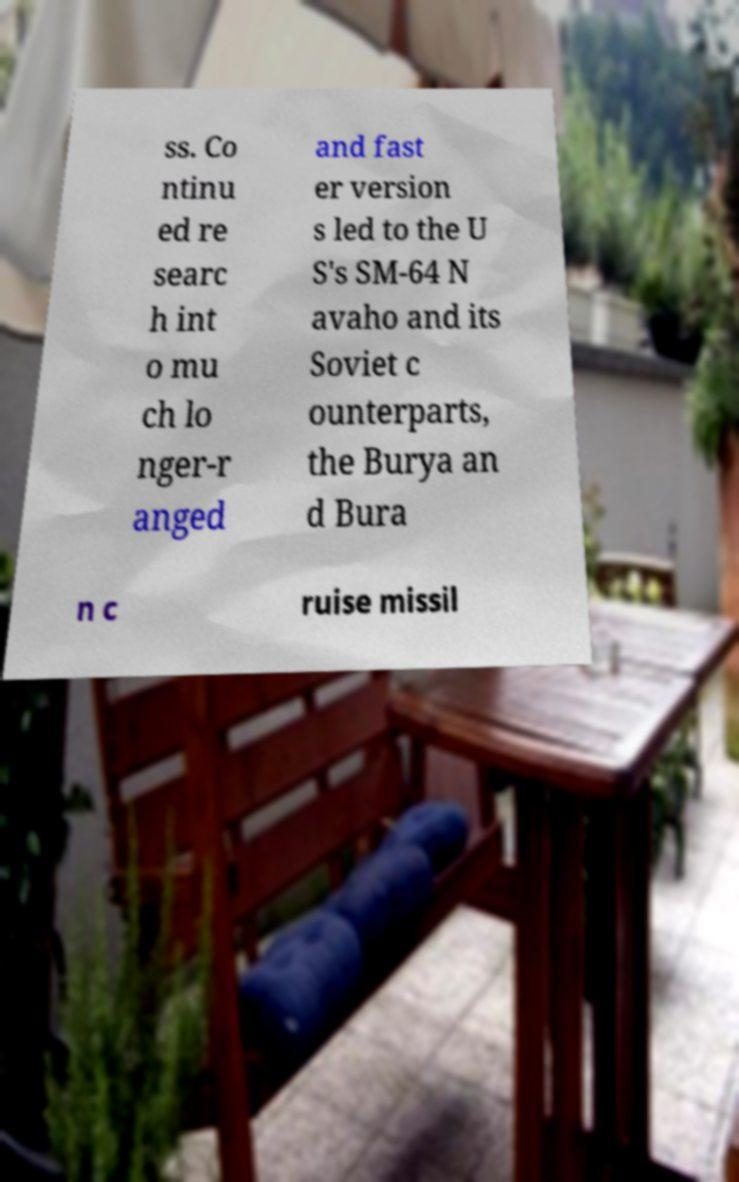Could you assist in decoding the text presented in this image and type it out clearly? ss. Co ntinu ed re searc h int o mu ch lo nger-r anged and fast er version s led to the U S's SM-64 N avaho and its Soviet c ounterparts, the Burya an d Bura n c ruise missil 